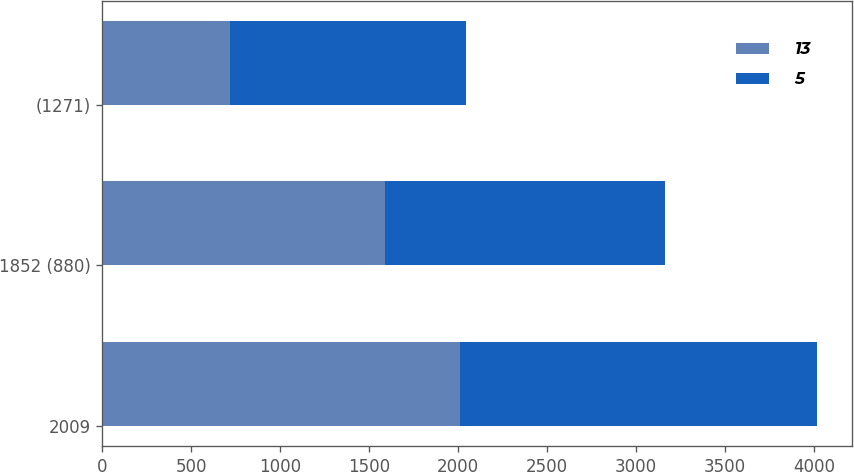<chart> <loc_0><loc_0><loc_500><loc_500><stacked_bar_chart><ecel><fcel>2009<fcel>1852 (880)<fcel>(1271)<nl><fcel>13<fcel>2008<fcel>1589<fcel>721<nl><fcel>5<fcel>2007<fcel>1571<fcel>1326<nl></chart> 